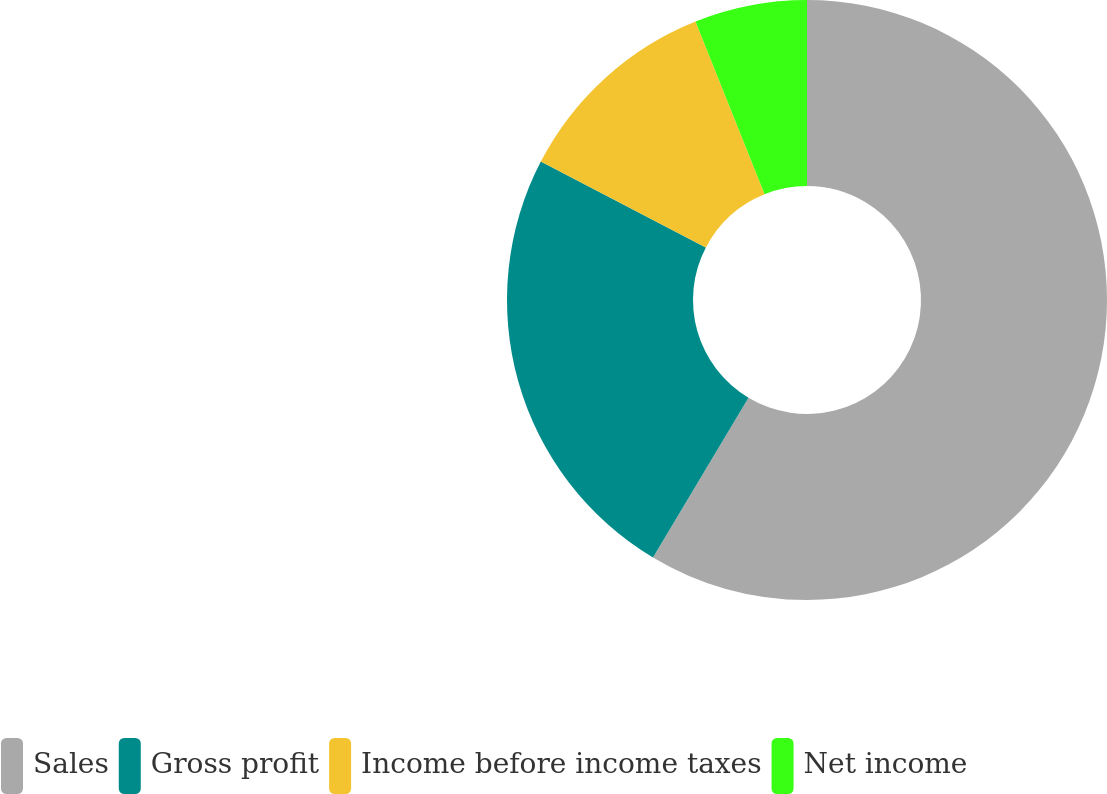<chart> <loc_0><loc_0><loc_500><loc_500><pie_chart><fcel>Sales<fcel>Gross profit<fcel>Income before income taxes<fcel>Net income<nl><fcel>58.58%<fcel>24.05%<fcel>11.31%<fcel>6.06%<nl></chart> 